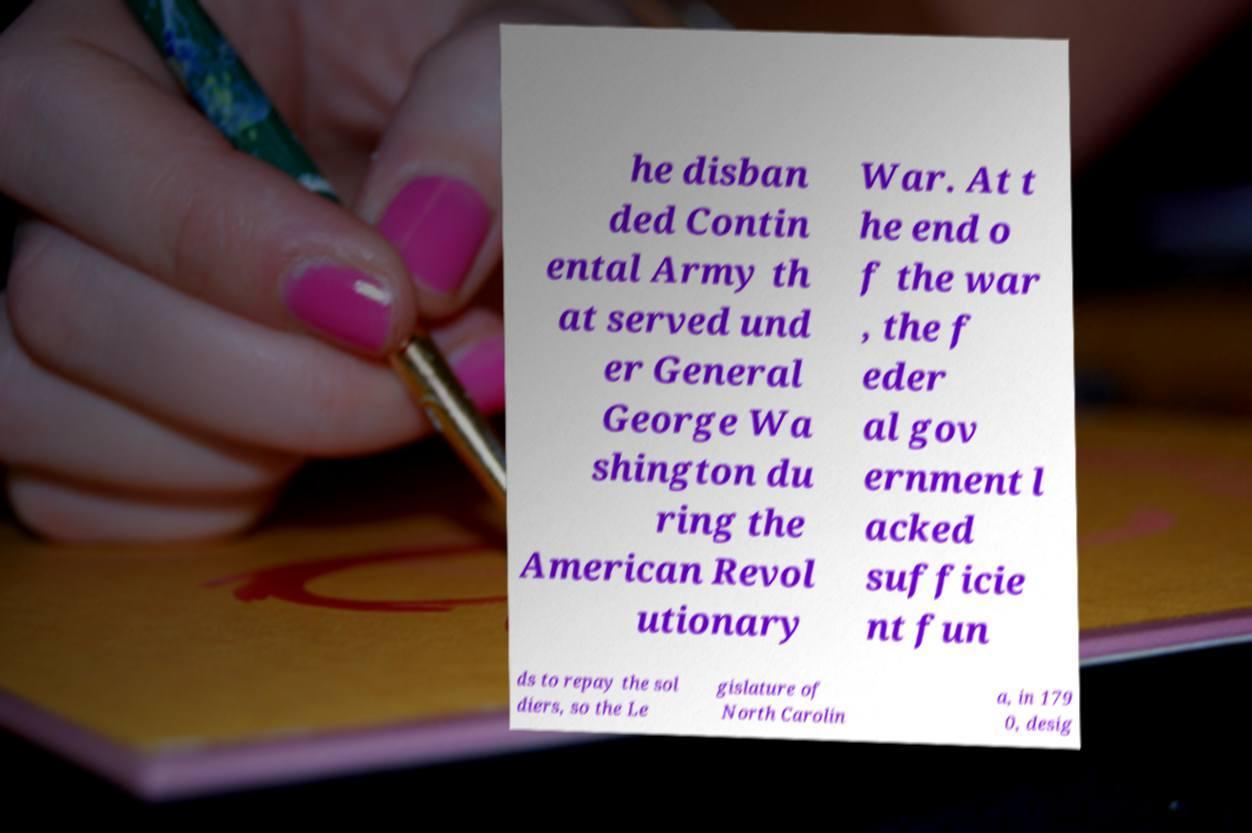Could you extract and type out the text from this image? he disban ded Contin ental Army th at served und er General George Wa shington du ring the American Revol utionary War. At t he end o f the war , the f eder al gov ernment l acked sufficie nt fun ds to repay the sol diers, so the Le gislature of North Carolin a, in 179 0, desig 